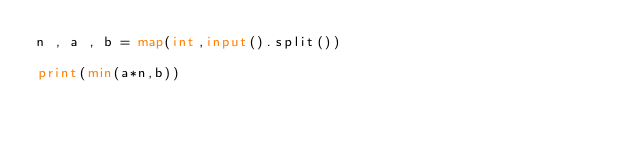Convert code to text. <code><loc_0><loc_0><loc_500><loc_500><_Python_>n , a , b = map(int,input().split())

print(min(a*n,b))</code> 